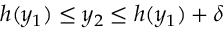Convert formula to latex. <formula><loc_0><loc_0><loc_500><loc_500>h ( y _ { 1 } ) \leq y _ { 2 } \leq h ( y _ { 1 } ) + \delta</formula> 